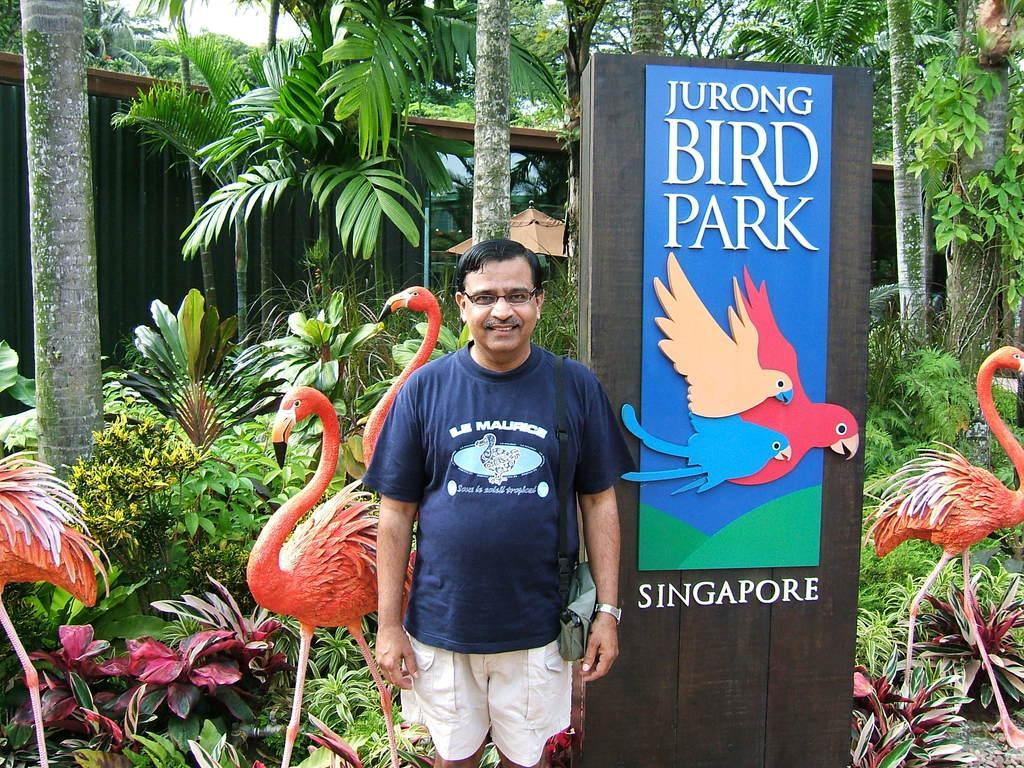Describe this image in one or two sentences. As we can see in the image there are plants, trees, banner, a man standing over here and there are crane statues. 